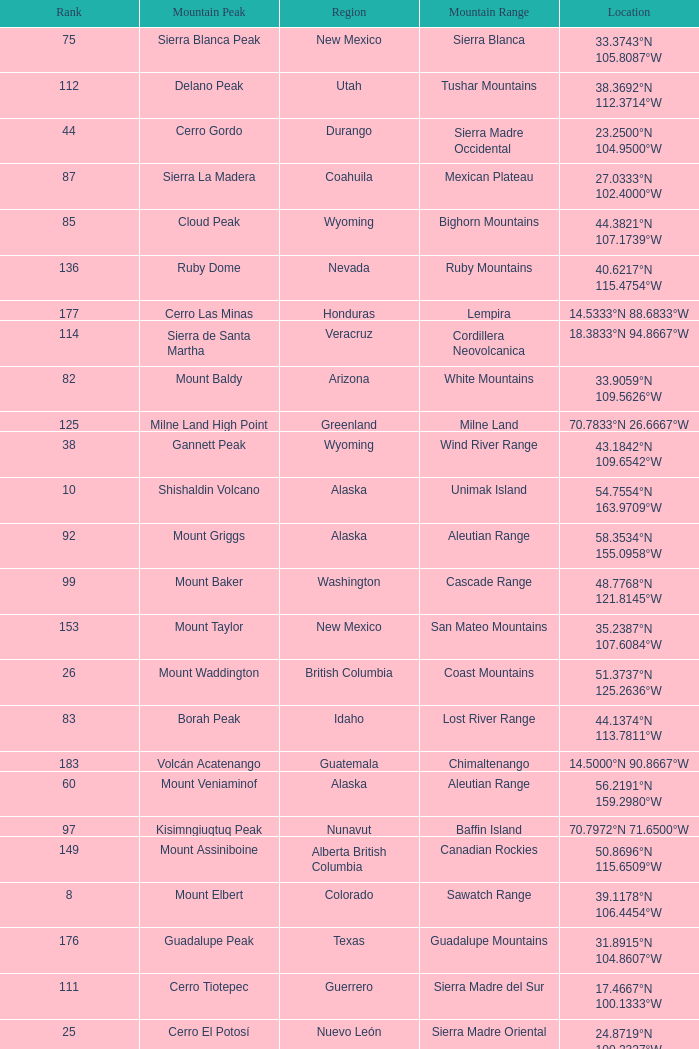Which Mountain Peak has a Region of baja california, and a Location of 28.1301°n 115.2206°w? Isla Cedros High Point. 